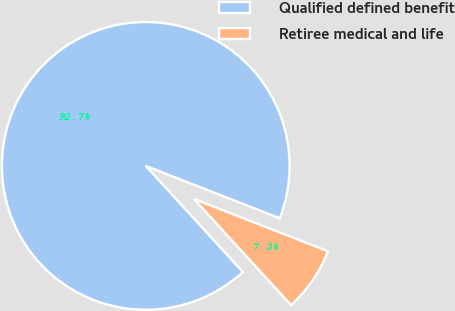Convert chart. <chart><loc_0><loc_0><loc_500><loc_500><pie_chart><fcel>Qualified defined benefit<fcel>Retiree medical and life<nl><fcel>92.72%<fcel>7.28%<nl></chart> 